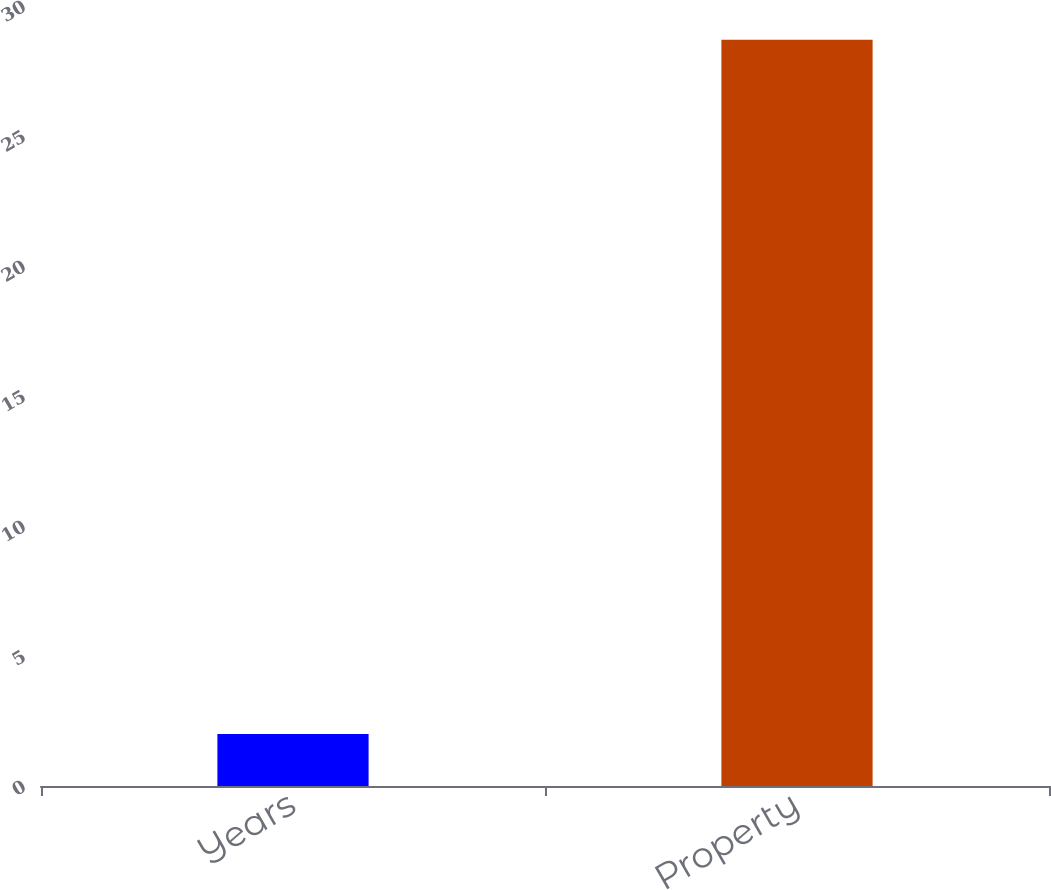Convert chart. <chart><loc_0><loc_0><loc_500><loc_500><bar_chart><fcel>Years<fcel>Property<nl><fcel>2<fcel>28.7<nl></chart> 